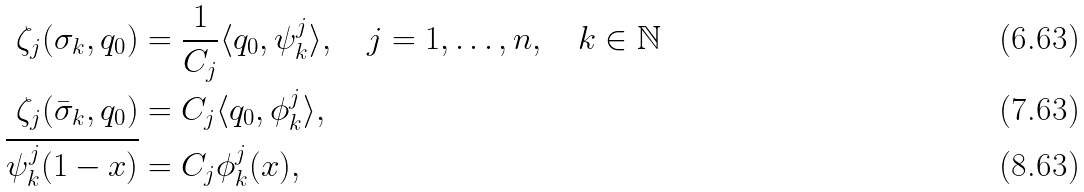<formula> <loc_0><loc_0><loc_500><loc_500>\zeta _ { j } ( \sigma _ { k } , q _ { 0 } ) & = \frac { 1 } { C _ { j } } \langle q _ { 0 } , \psi _ { k } ^ { j } \rangle , \quad j = 1 , \dots , n , \quad k \in { \mathbb { N } } \\ \zeta _ { j } ( \bar { \sigma } _ { k } , q _ { 0 } ) & = C _ { j } \langle q _ { 0 } , \phi _ { k } ^ { j } \rangle , \\ \overline { \psi _ { k } ^ { j } ( 1 - x ) } & = C _ { j } \phi _ { k } ^ { j } ( x ) ,</formula> 